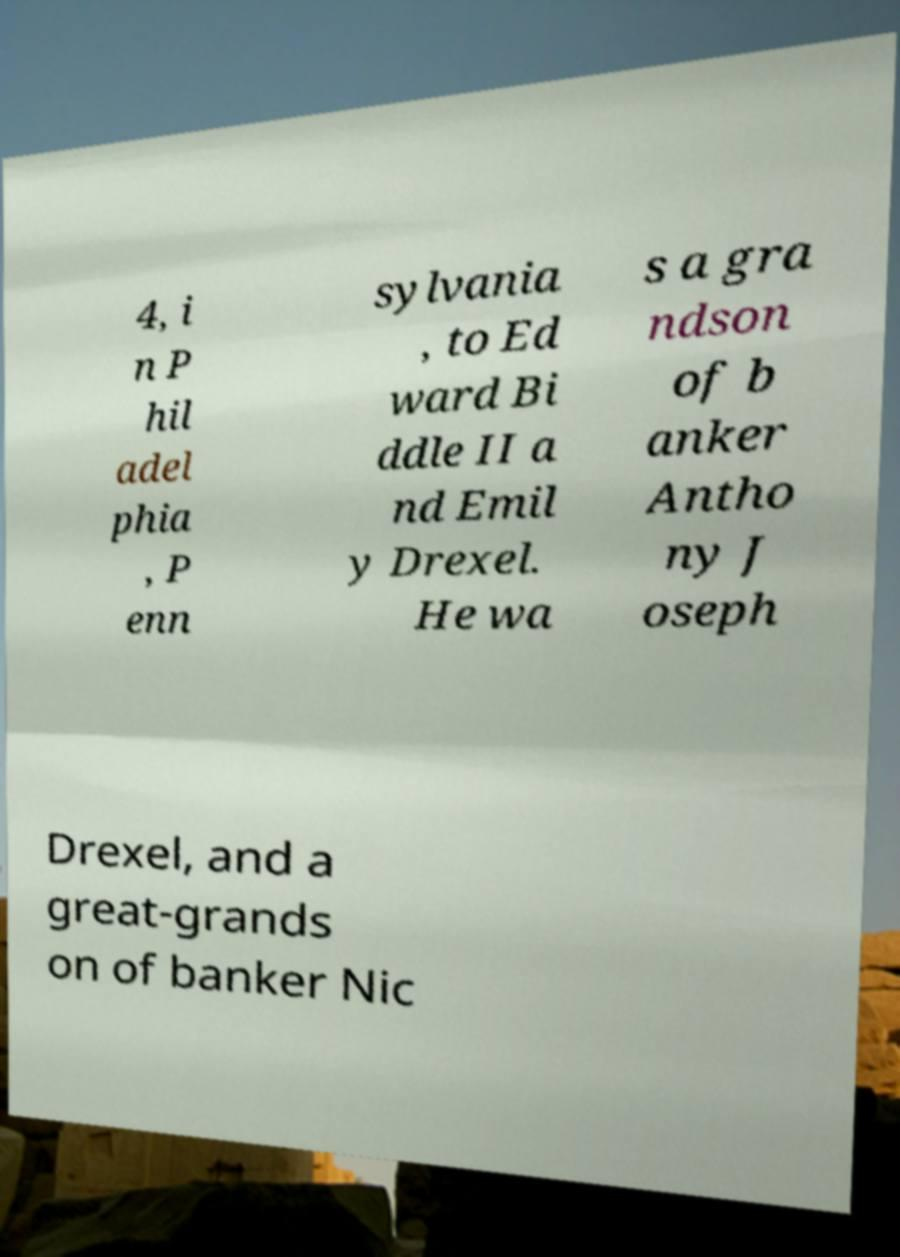Please identify and transcribe the text found in this image. 4, i n P hil adel phia , P enn sylvania , to Ed ward Bi ddle II a nd Emil y Drexel. He wa s a gra ndson of b anker Antho ny J oseph Drexel, and a great-grands on of banker Nic 